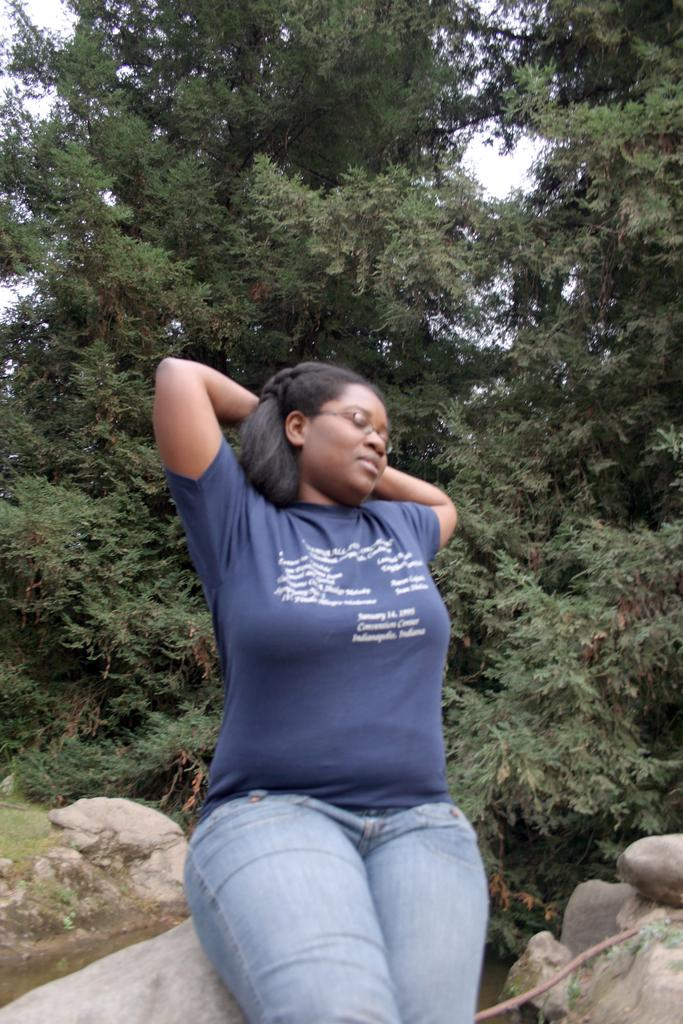Who is the main subject in the image? There is a girl in the image. What is the girl doing in the image? The girl is sitting on a rock. What can be seen behind the girl? There are stones behind the girl. What type of natural environment is visible in the image? There are trees visible in the image. What type of plants can be seen growing inside the drawer in the image? There is no drawer present in the image, and therefore no plants growing inside it. 